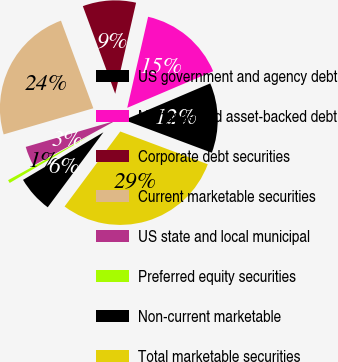Convert chart. <chart><loc_0><loc_0><loc_500><loc_500><pie_chart><fcel>US government and agency debt<fcel>Mortgage and asset-backed debt<fcel>Corporate debt securities<fcel>Current marketable securities<fcel>US state and local municipal<fcel>Preferred equity securities<fcel>Non-current marketable<fcel>Total marketable securities<nl><fcel>12.11%<fcel>15.01%<fcel>9.22%<fcel>23.88%<fcel>3.44%<fcel>0.55%<fcel>6.33%<fcel>29.47%<nl></chart> 